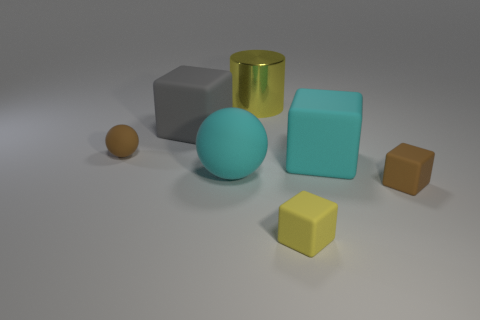Are there any other things that are the same material as the big yellow cylinder?
Keep it short and to the point. No. There is a brown thing that is on the right side of the small brown thing on the left side of the small brown object that is in front of the cyan rubber sphere; what shape is it?
Offer a terse response. Cube. Are there more yellow cubes that are in front of the big matte ball than red metallic cylinders?
Make the answer very short. Yes. There is a yellow thing that is in front of the gray matte cube; is its shape the same as the gray thing?
Provide a succinct answer. Yes. There is a yellow thing that is behind the cyan block; what is its material?
Your response must be concise. Metal. How many brown matte things have the same shape as the big gray rubber thing?
Provide a succinct answer. 1. There is a yellow thing that is to the left of the thing in front of the small brown matte cube; what is it made of?
Offer a very short reply. Metal. What shape is the small object that is the same color as the big cylinder?
Your answer should be compact. Cube. Are there any large things that have the same material as the large cyan block?
Provide a short and direct response. Yes. There is a big gray object; what shape is it?
Offer a very short reply. Cube. 